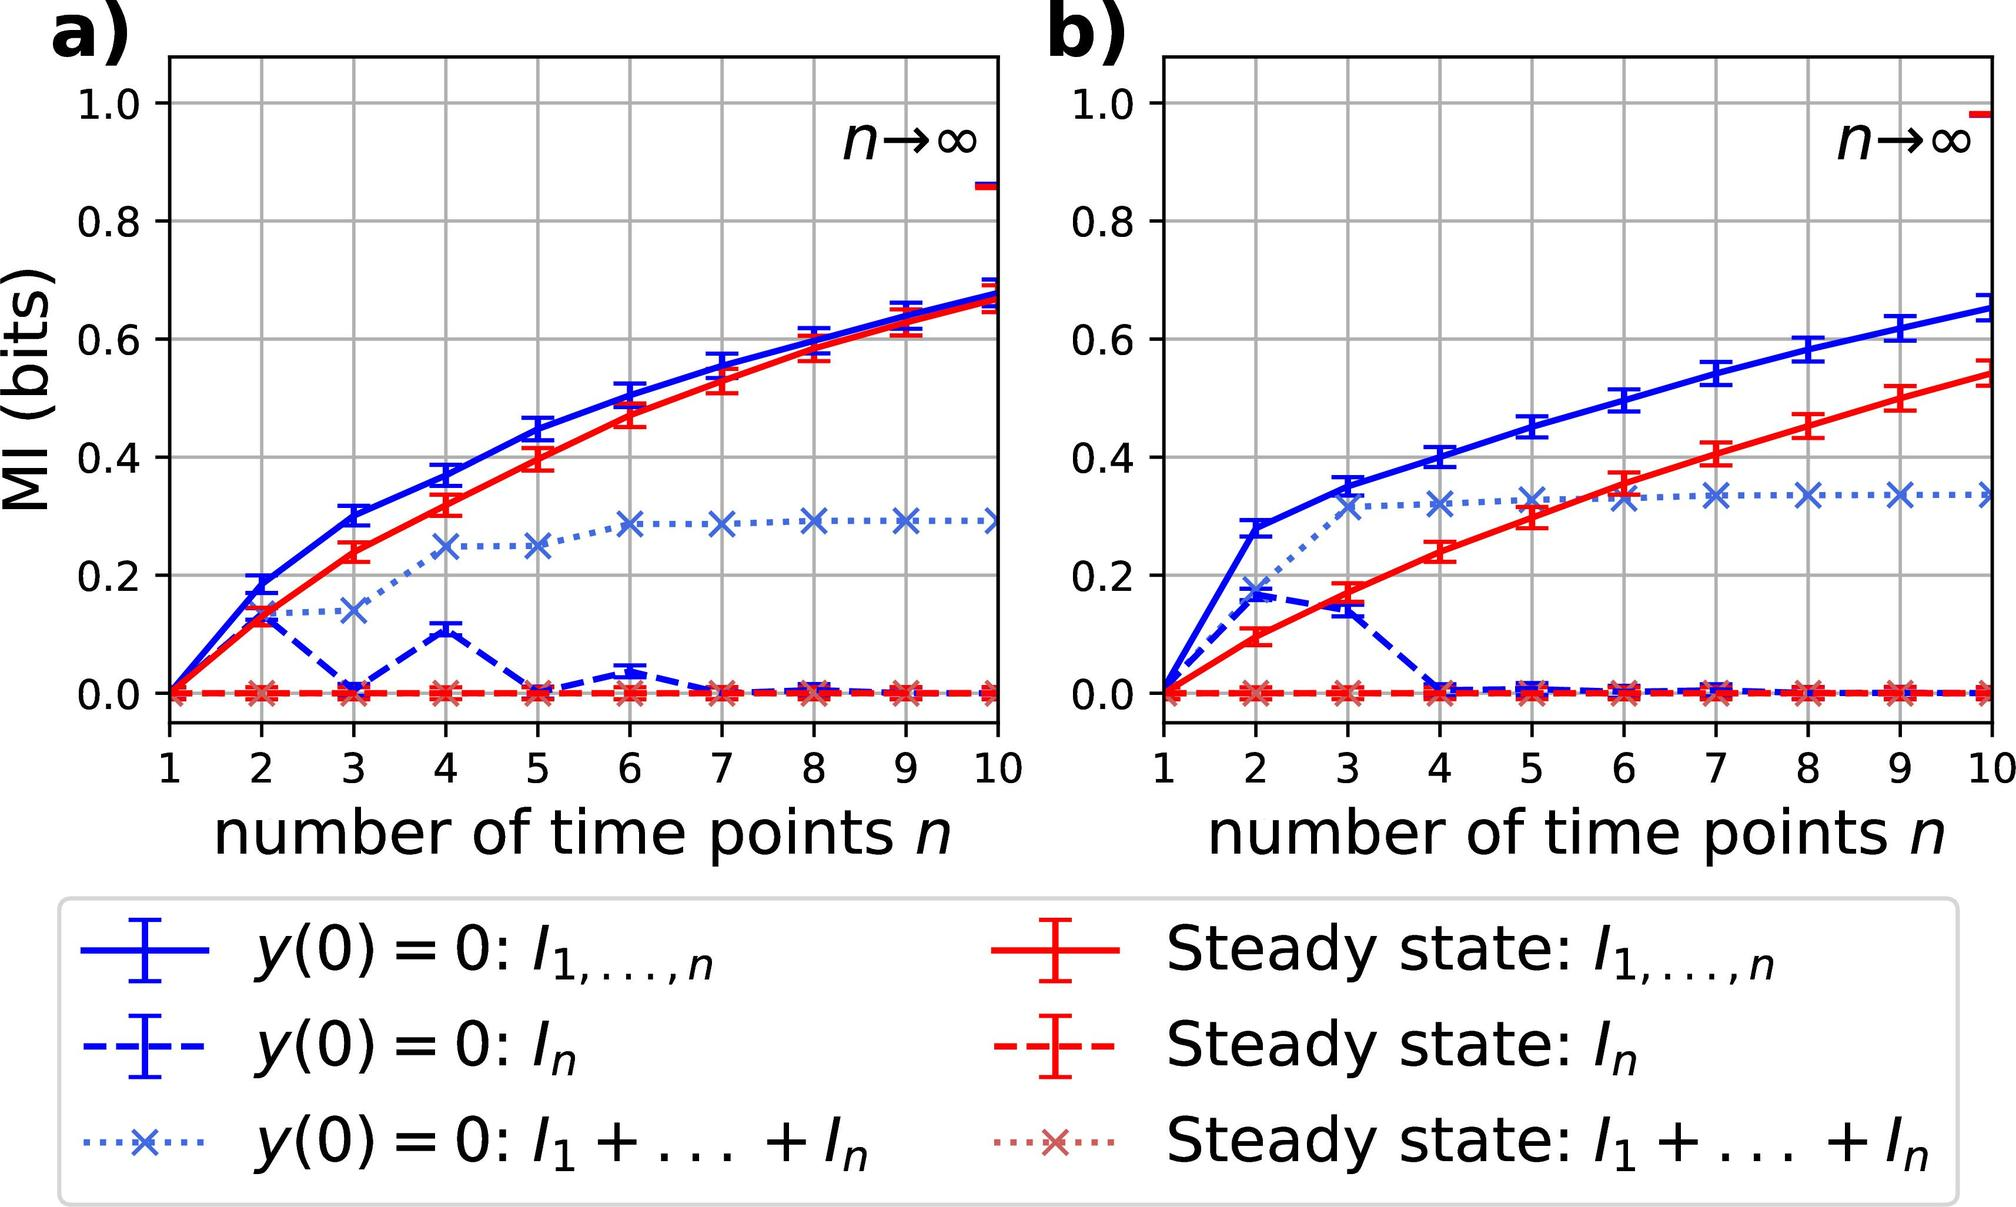Which initial condition in figure a) exhibits the least increase in mutual information (MI) as the number of time points \( n \) increases? A. \( y(0) = 0: l_1, \ldots, n \) B. \( y(0) = 0: I_n \) C. \( y(0) = 0: I_1 + \ldots + I_n \) D. \( y(0) = 0: 1, \ldots, n \) Upon examining figure a), we can identify that the initial condition described by \( y(0) = 0: I_1 + \ldots + I_n \), represented by the dotted blue line with 'x' markers, shows a remarkable stability in mutual information (MI) as the number of time points \( n \) increases, relative to the other conditions. The line's horizontal trend indicates that the MI does not substantially vary with an increase in data points, thereby suggesting that this condition upholds informational consistency over time. In contrast, the other lines on the graph demonstrate a steady rise, marking a significant increase in MI with additional time points. Thus, it is sensible to conclude that option C) is the most appropriate answer for the condition that exhibits the least increase in MI. 